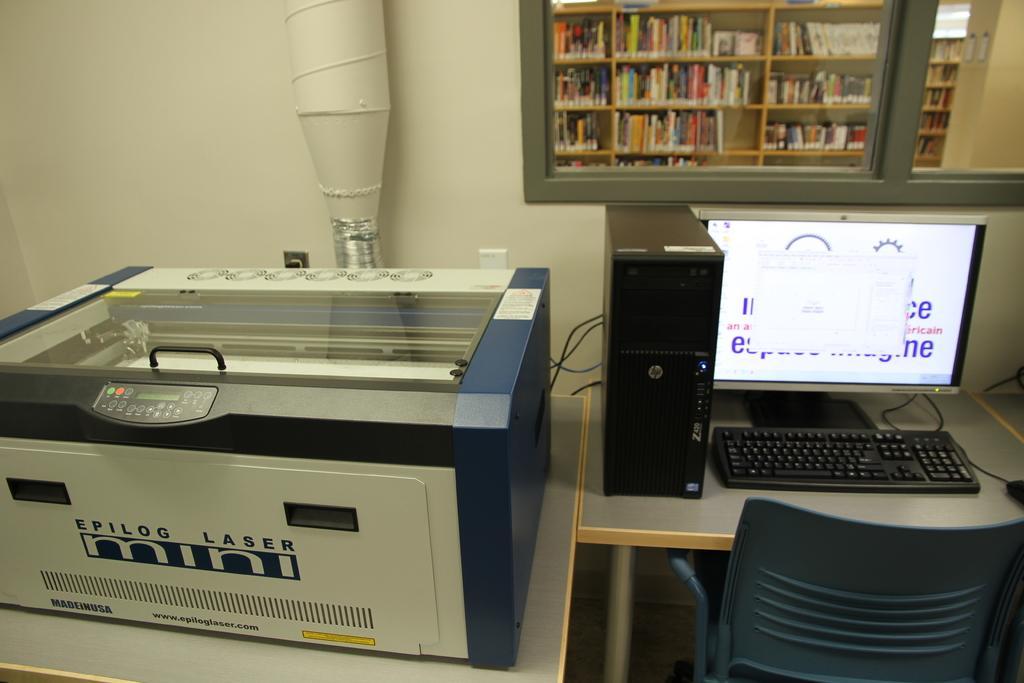In one or two sentences, can you explain what this image depicts? In the image we can see machine. And on the right side we can see the monitor on the table. And bottom we can see the chair. And coming to the background we can see the books,wall,glass and pipe. 